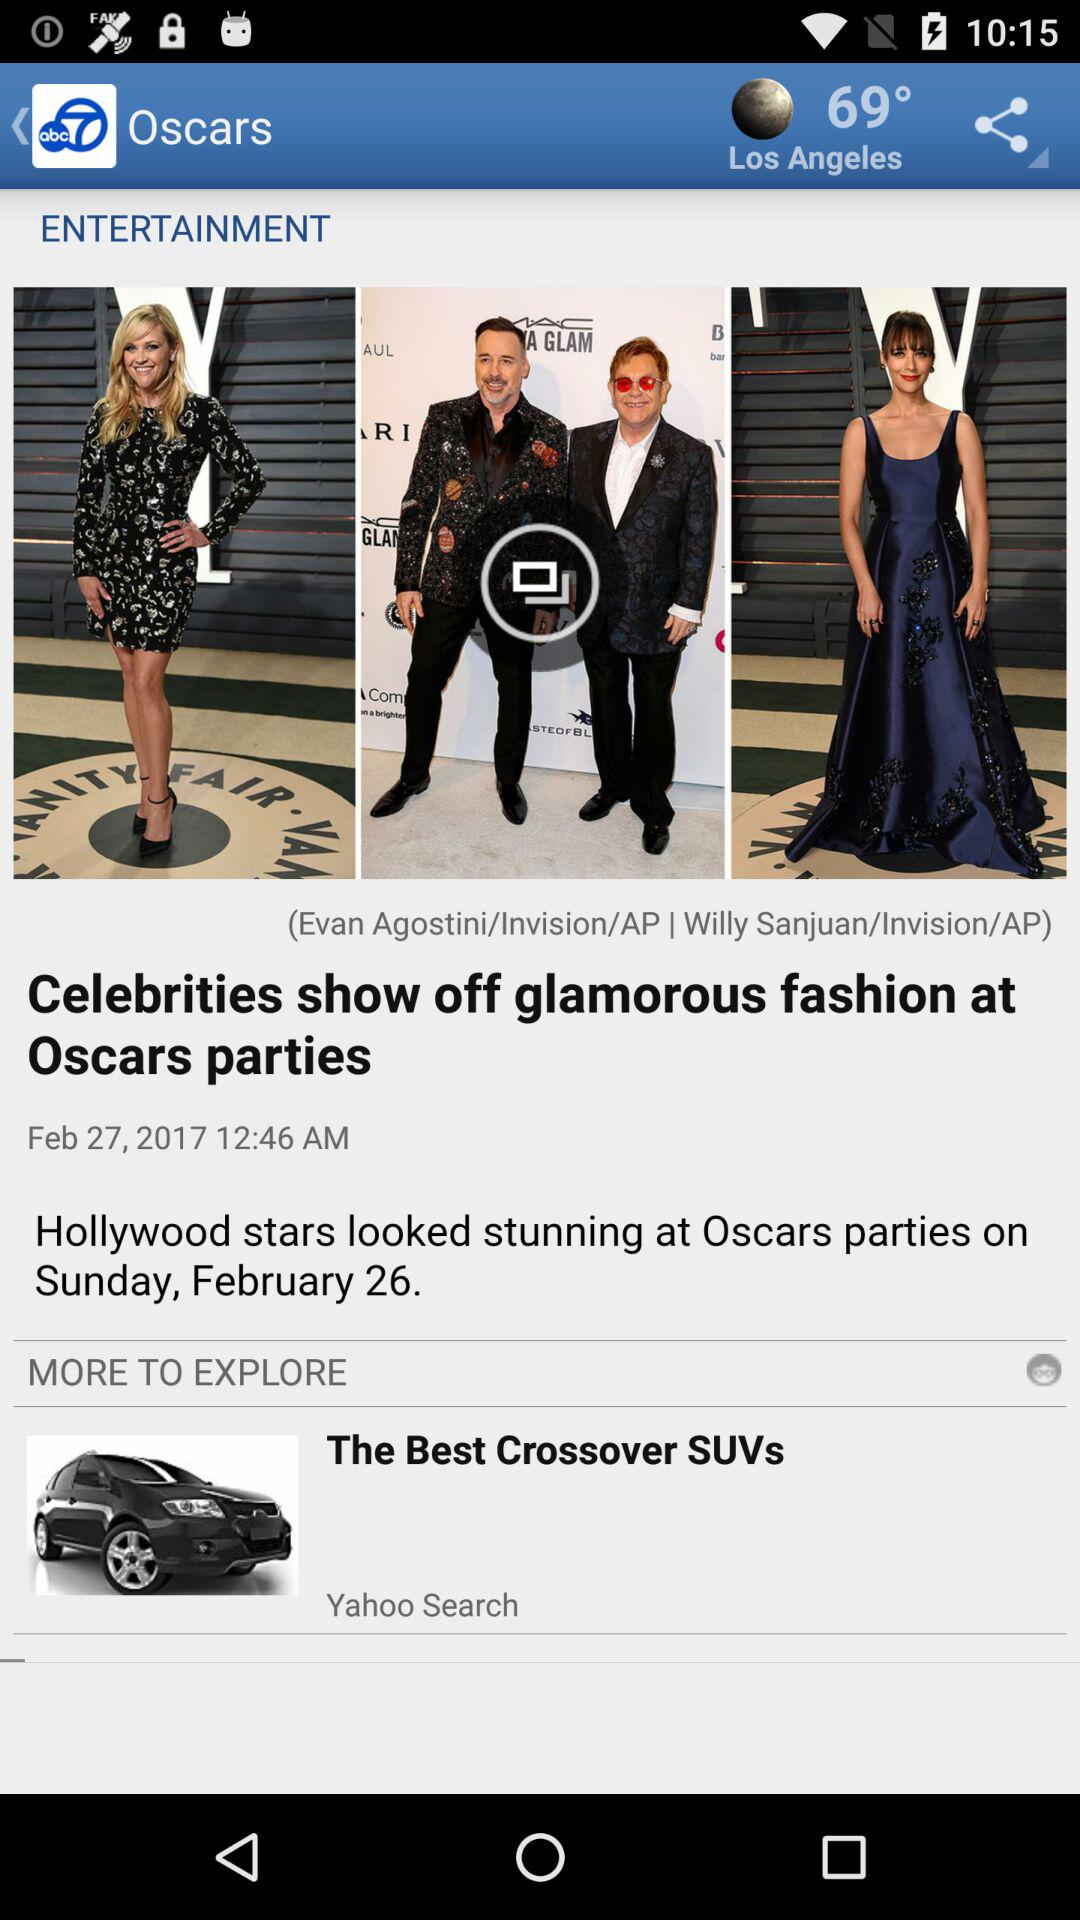What is the weather in Los Angeles?
When the provided information is insufficient, respond with <no answer>. <no answer> 